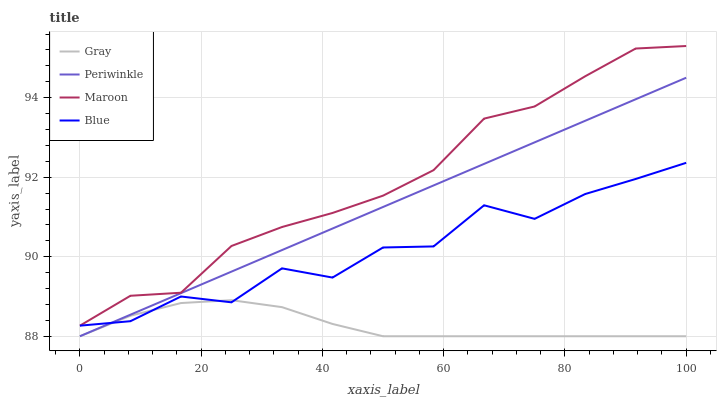Does Gray have the minimum area under the curve?
Answer yes or no. Yes. Does Maroon have the maximum area under the curve?
Answer yes or no. Yes. Does Periwinkle have the minimum area under the curve?
Answer yes or no. No. Does Periwinkle have the maximum area under the curve?
Answer yes or no. No. Is Periwinkle the smoothest?
Answer yes or no. Yes. Is Blue the roughest?
Answer yes or no. Yes. Is Gray the smoothest?
Answer yes or no. No. Is Gray the roughest?
Answer yes or no. No. Does Maroon have the lowest value?
Answer yes or no. No. Does Maroon have the highest value?
Answer yes or no. Yes. Does Periwinkle have the highest value?
Answer yes or no. No. Is Gray less than Maroon?
Answer yes or no. Yes. Is Maroon greater than Periwinkle?
Answer yes or no. Yes. Does Blue intersect Gray?
Answer yes or no. Yes. Is Blue less than Gray?
Answer yes or no. No. Is Blue greater than Gray?
Answer yes or no. No. Does Gray intersect Maroon?
Answer yes or no. No. 